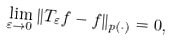<formula> <loc_0><loc_0><loc_500><loc_500>\lim _ { \varepsilon \to 0 } \| T _ { \varepsilon } f - f \| _ { p ( \cdot ) } = 0 ,</formula> 